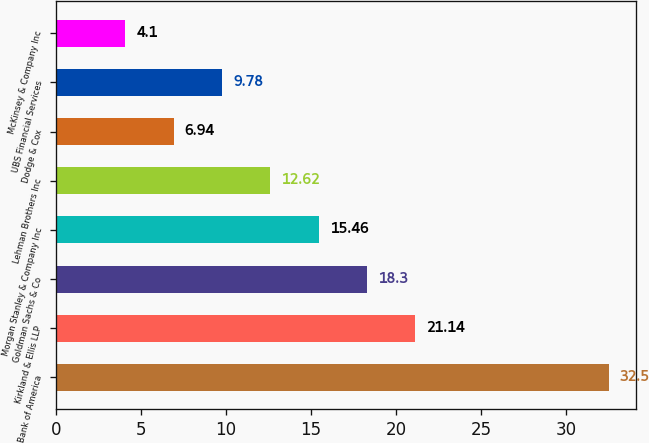Convert chart. <chart><loc_0><loc_0><loc_500><loc_500><bar_chart><fcel>Bank of America<fcel>Kirkland & Ellis LLP<fcel>Goldman Sachs & Co<fcel>Morgan Stanley & Company Inc<fcel>Lehman Brothers Inc<fcel>Dodge & Cox<fcel>UBS Financial Services<fcel>McKinsey & Company Inc<nl><fcel>32.5<fcel>21.14<fcel>18.3<fcel>15.46<fcel>12.62<fcel>6.94<fcel>9.78<fcel>4.1<nl></chart> 